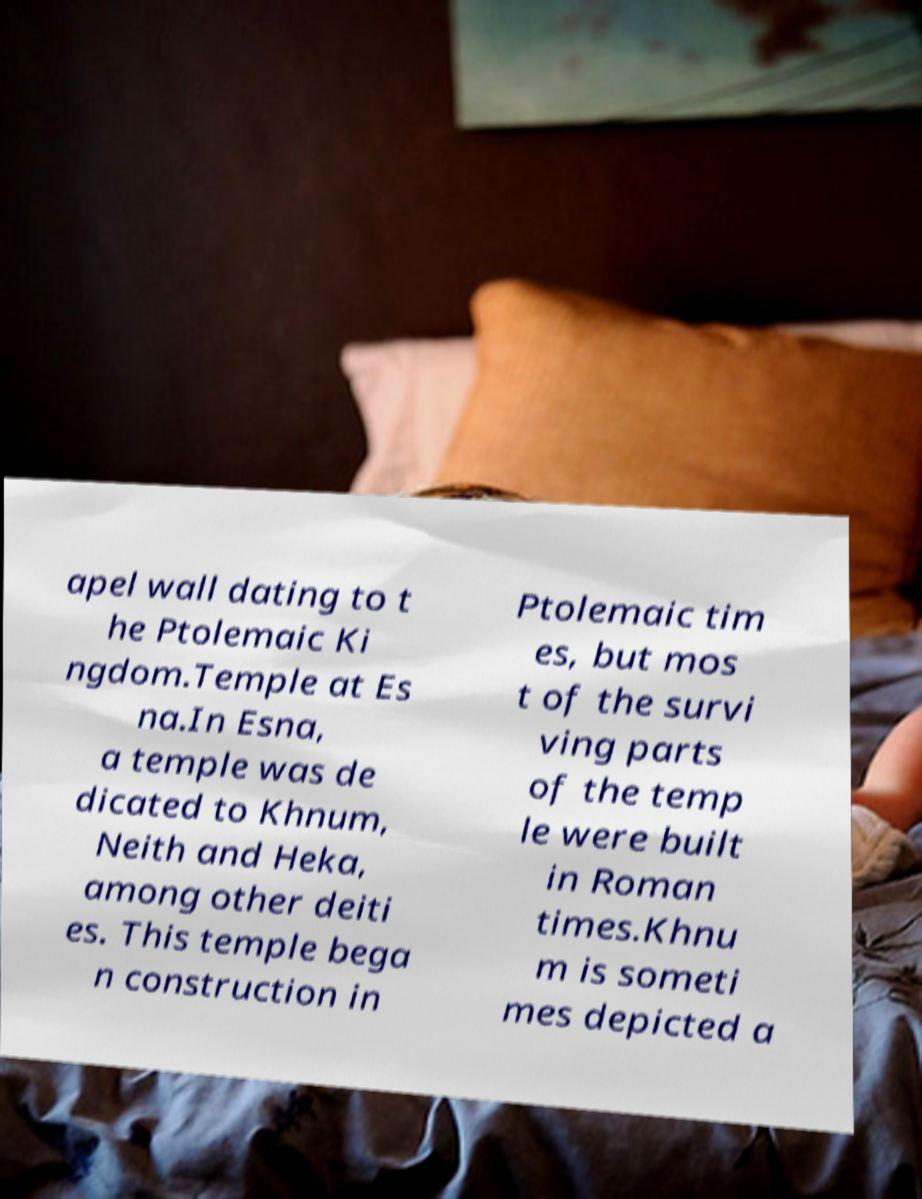Please identify and transcribe the text found in this image. apel wall dating to t he Ptolemaic Ki ngdom.Temple at Es na.In Esna, a temple was de dicated to Khnum, Neith and Heka, among other deiti es. This temple bega n construction in Ptolemaic tim es, but mos t of the survi ving parts of the temp le were built in Roman times.Khnu m is someti mes depicted a 